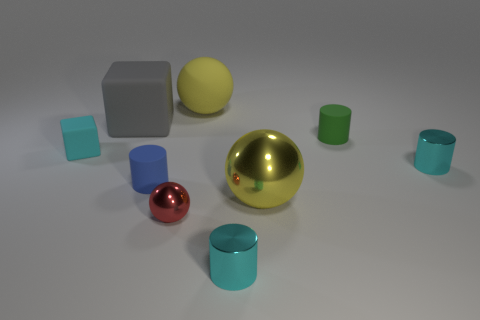Subtract 1 cylinders. How many cylinders are left? 3 Add 1 gray rubber cylinders. How many objects exist? 10 Subtract all cubes. How many objects are left? 7 Subtract all blue matte cubes. Subtract all tiny cylinders. How many objects are left? 5 Add 5 red spheres. How many red spheres are left? 6 Add 9 large blue things. How many large blue things exist? 9 Subtract 0 green spheres. How many objects are left? 9 